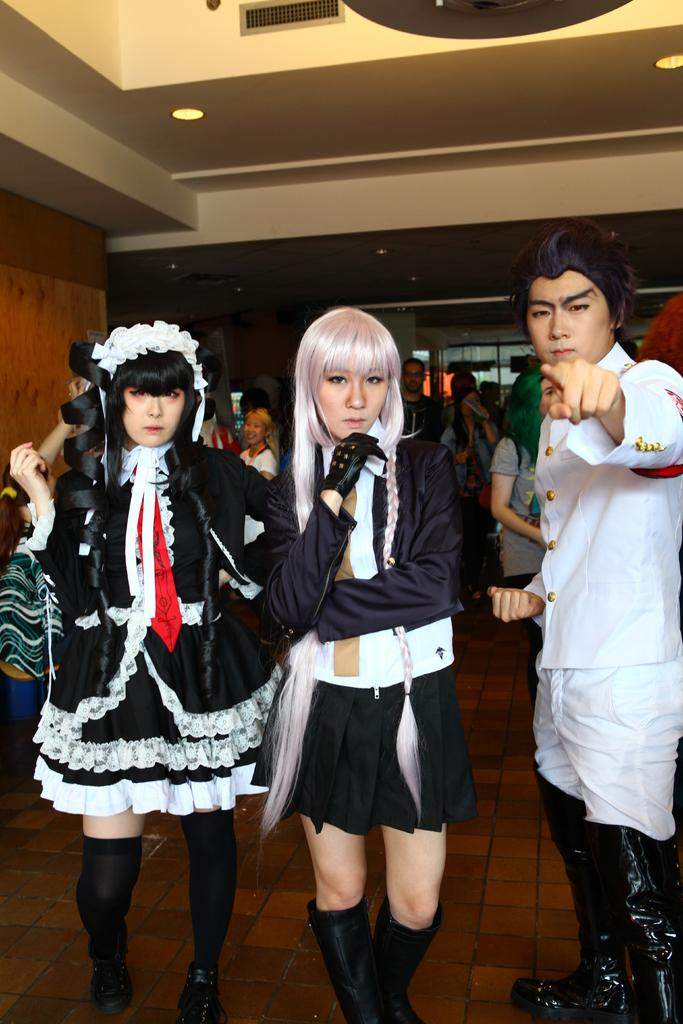How many people are in the room in the image? There are many people in the room in the image. Can you describe the people in the front? Three people are standing in the front. What are the three people in the front wearing? The three people in the front are wearing different costumes. What can be seen on the left side of the room? There is a wooden wall on the left side of the room. How many fingers can be seen on the observation deck in the image? There is no observation deck or mention of fingers in the image; it features a room with people and a wooden wall. 